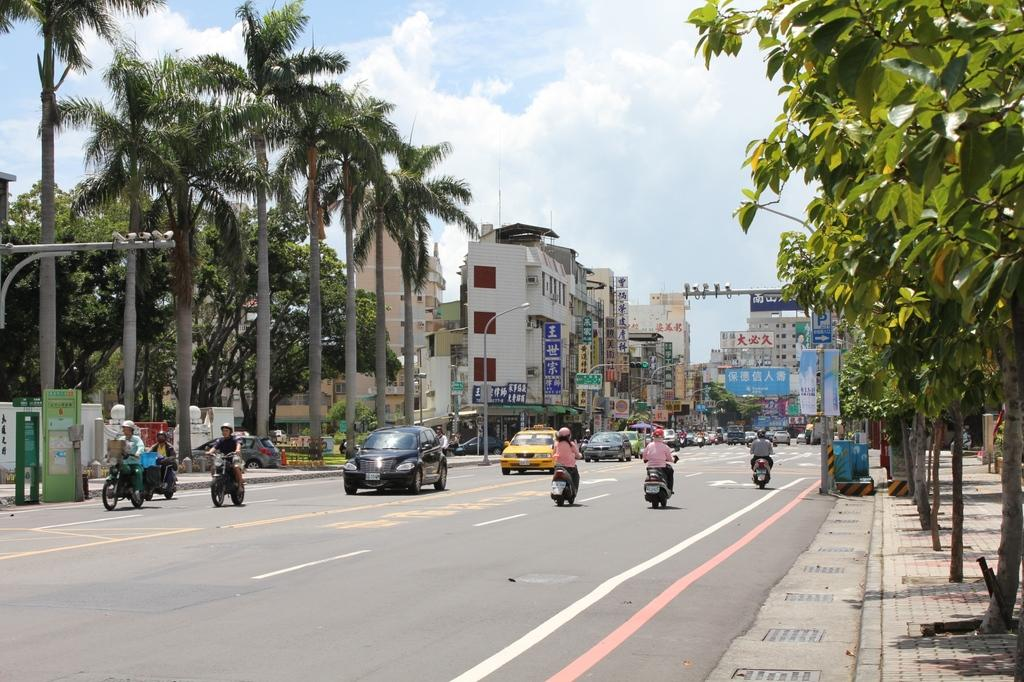What is the condition of the sky in the image? The sky is cloudy in the image. What type of structures can be seen in the image? There are buildings with hoardings in the image. What is present on the road in the image? Vehicles are present on the road in the image. What are people doing with motorbikes in the image? There are people sitting on motorbikes in the image. What type of vegetation is visible in the image? Trees are visible in the image. What is the tall, vertical object in the image? There is a light pole in the image. What type of apparatus is being used to apply glue to the finger in the image? There is no apparatus, glue, or finger present in the image. 